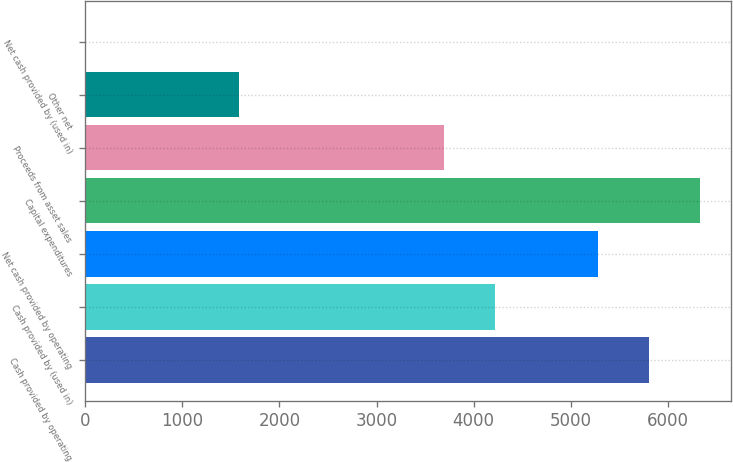<chart> <loc_0><loc_0><loc_500><loc_500><bar_chart><fcel>Cash provided by operating<fcel>Cash provided by (used in)<fcel>Net cash provided by operating<fcel>Capital expenditures<fcel>Proceeds from asset sales<fcel>Other net<fcel>Net cash provided by (used in)<nl><fcel>5801.3<fcel>4219.4<fcel>5274<fcel>6328.6<fcel>3692.1<fcel>1582.9<fcel>1<nl></chart> 